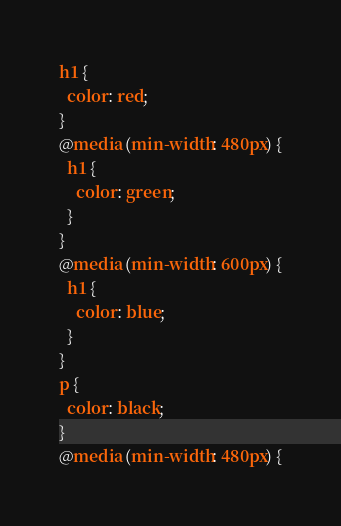Convert code to text. <code><loc_0><loc_0><loc_500><loc_500><_CSS_>h1 {
  color: red;
}
@media (min-width: 480px) {
  h1 {
    color: green;
  }
}
@media (min-width: 600px) {
  h1 {
    color: blue;
  }
}
p {
  color: black;
}
@media (min-width: 480px) {</code> 